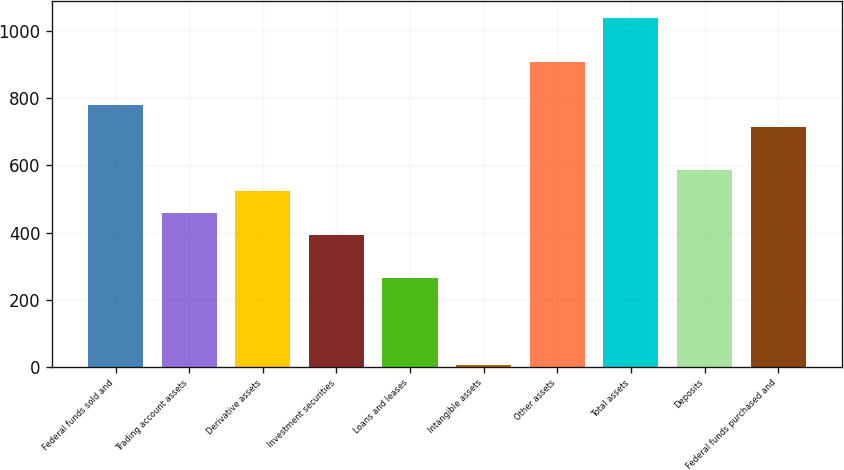Convert chart to OTSL. <chart><loc_0><loc_0><loc_500><loc_500><bar_chart><fcel>Federal funds sold and<fcel>Trading account assets<fcel>Derivative assets<fcel>Investment securities<fcel>Loans and leases<fcel>Intangible assets<fcel>Other assets<fcel>Total assets<fcel>Deposits<fcel>Federal funds purchased and<nl><fcel>780.76<fcel>457.86<fcel>522.44<fcel>393.28<fcel>264.12<fcel>5.8<fcel>909.92<fcel>1039.08<fcel>587.02<fcel>716.18<nl></chart> 